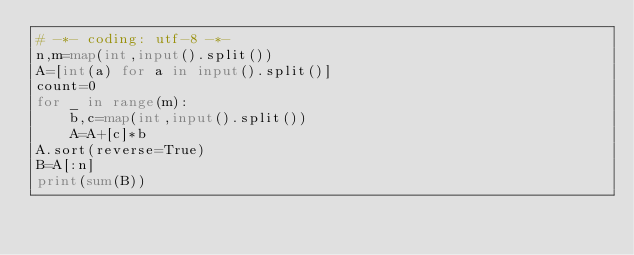Convert code to text. <code><loc_0><loc_0><loc_500><loc_500><_Python_># -*- coding: utf-8 -*-
n,m=map(int,input().split())
A=[int(a) for a in input().split()]
count=0
for _ in range(m):
    b,c=map(int,input().split())
    A=A+[c]*b
A.sort(reverse=True)
B=A[:n]
print(sum(B))</code> 